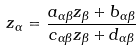Convert formula to latex. <formula><loc_0><loc_0><loc_500><loc_500>z _ { \alpha } = \frac { a _ { \alpha \beta } z _ { \beta } + b _ { \alpha \beta } } { c _ { \alpha \beta } z _ { \beta } + d _ { \alpha \beta } }</formula> 